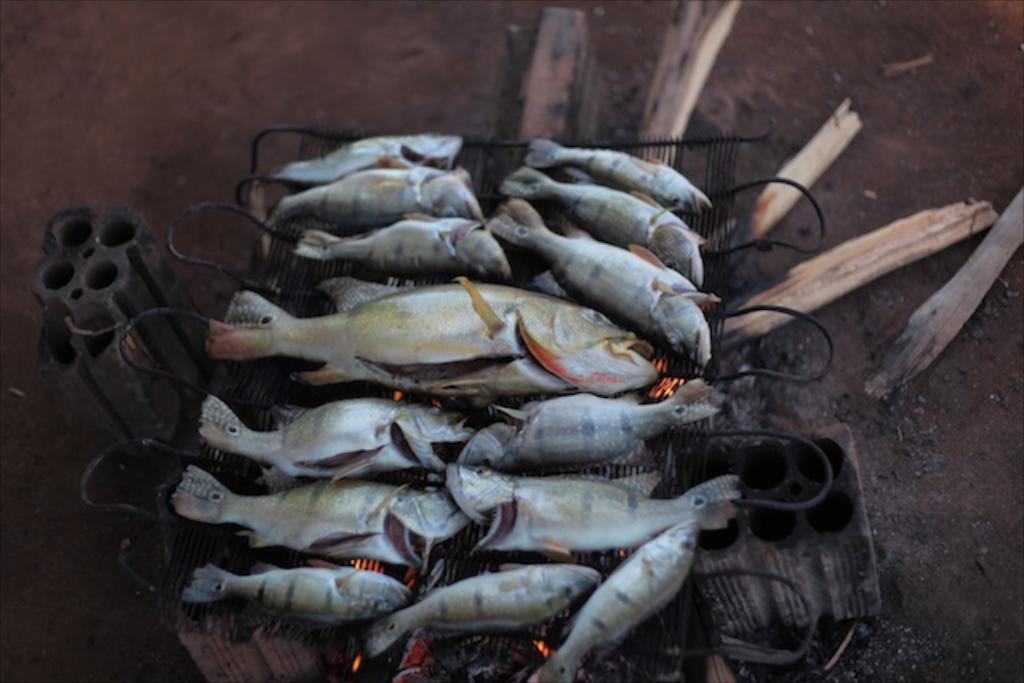Describe this image in one or two sentences. In the picture I can see fishes on a grill. I can also see wooden objects and some other objects. 